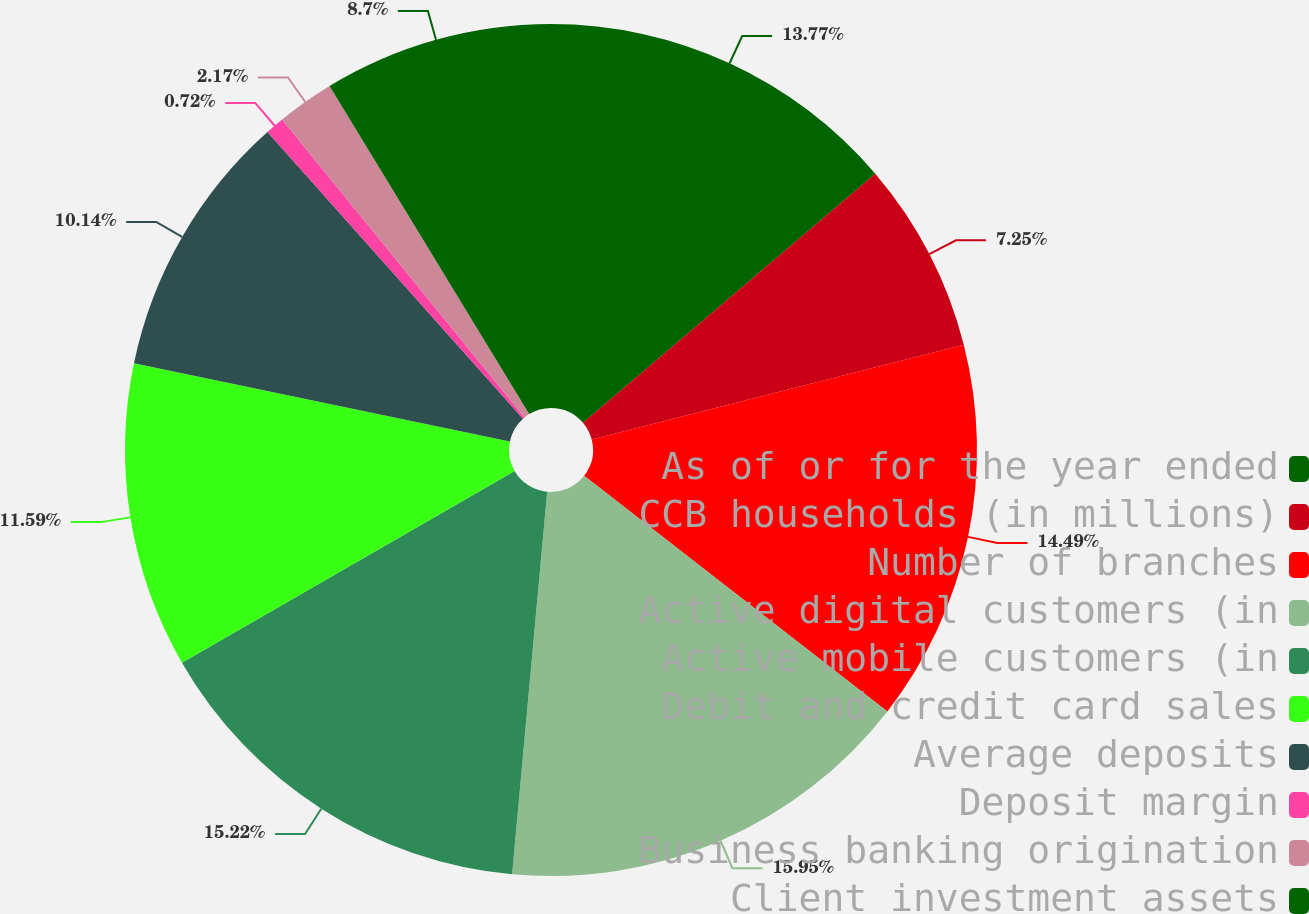Convert chart to OTSL. <chart><loc_0><loc_0><loc_500><loc_500><pie_chart><fcel>As of or for the year ended<fcel>CCB households (in millions)<fcel>Number of branches<fcel>Active digital customers (in<fcel>Active mobile customers (in<fcel>Debit and credit card sales<fcel>Average deposits<fcel>Deposit margin<fcel>Business banking origination<fcel>Client investment assets<nl><fcel>13.77%<fcel>7.25%<fcel>14.49%<fcel>15.94%<fcel>15.22%<fcel>11.59%<fcel>10.14%<fcel>0.72%<fcel>2.17%<fcel>8.7%<nl></chart> 